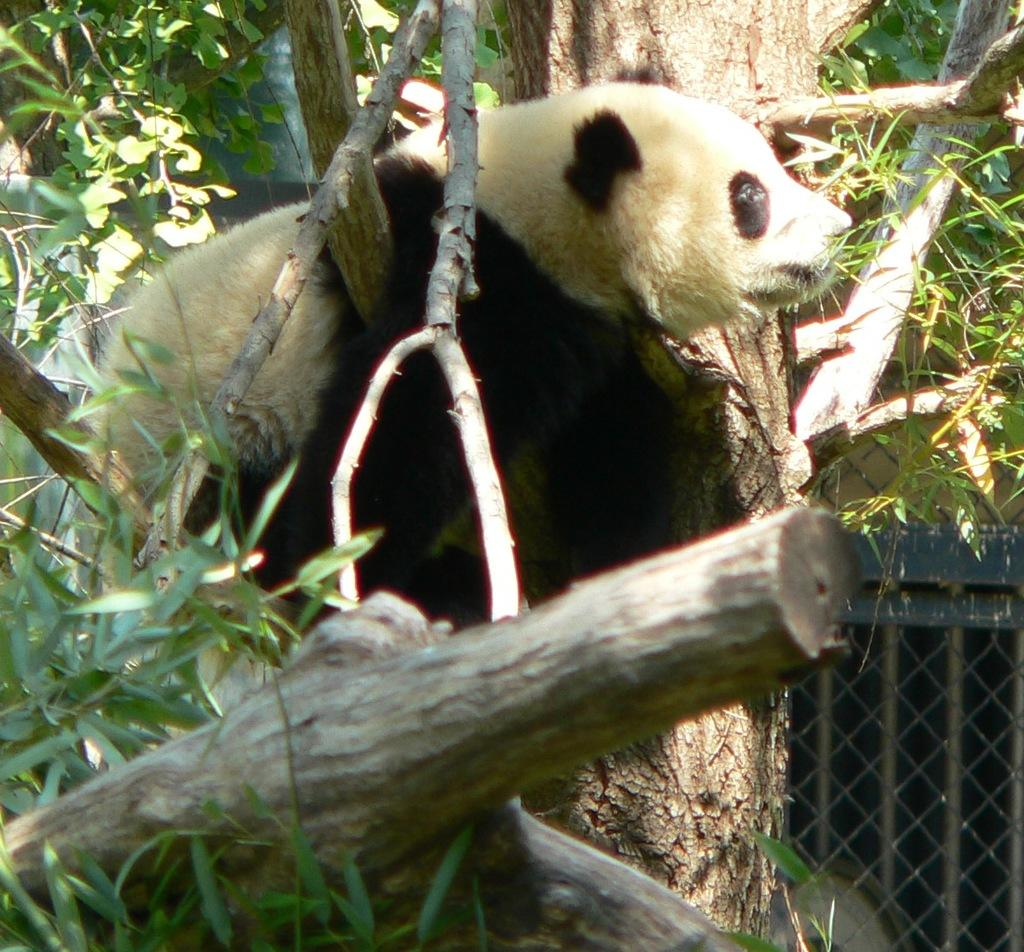What type of animal is in the image? The animal in the image has white and brown colors. Can you describe the background of the image? There is a window and trees with green color in the background of the image. What type of metal net can be seen surrounding the animal in the image? There is no metal net present in the image; the animal is not surrounded by any net. 